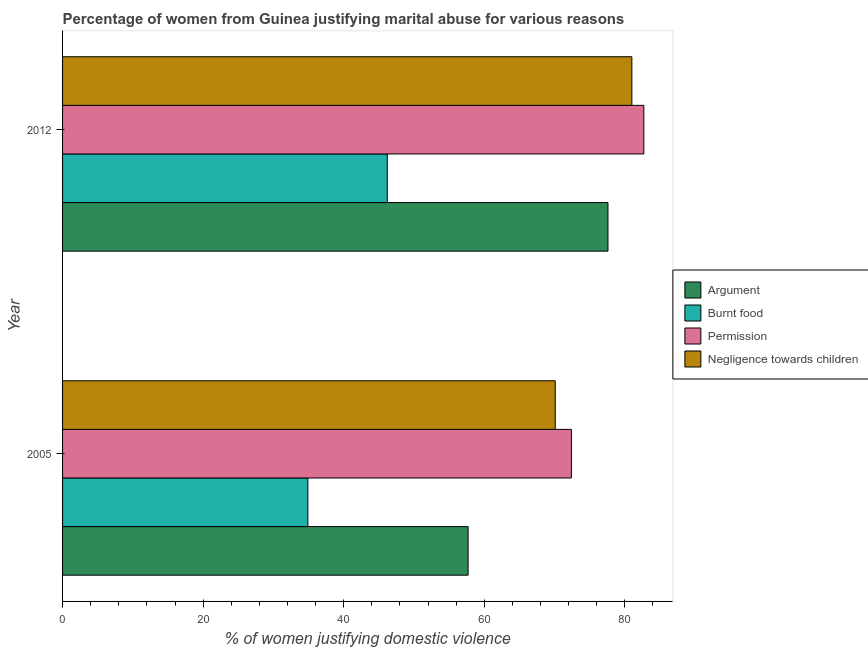How many different coloured bars are there?
Ensure brevity in your answer.  4. How many groups of bars are there?
Make the answer very short. 2. Are the number of bars per tick equal to the number of legend labels?
Your answer should be very brief. Yes. Are the number of bars on each tick of the Y-axis equal?
Give a very brief answer. Yes. How many bars are there on the 1st tick from the top?
Give a very brief answer. 4. How many bars are there on the 1st tick from the bottom?
Provide a short and direct response. 4. What is the label of the 2nd group of bars from the top?
Your answer should be compact. 2005. What is the percentage of women justifying abuse for showing negligence towards children in 2005?
Ensure brevity in your answer.  70.1. Across all years, what is the minimum percentage of women justifying abuse for burning food?
Offer a terse response. 34.9. What is the total percentage of women justifying abuse for burning food in the graph?
Keep it short and to the point. 81.1. What is the difference between the percentage of women justifying abuse in the case of an argument in 2005 and that in 2012?
Provide a short and direct response. -19.9. What is the difference between the percentage of women justifying abuse for showing negligence towards children in 2012 and the percentage of women justifying abuse for going without permission in 2005?
Ensure brevity in your answer.  8.6. What is the average percentage of women justifying abuse in the case of an argument per year?
Ensure brevity in your answer.  67.65. In the year 2012, what is the difference between the percentage of women justifying abuse for burning food and percentage of women justifying abuse in the case of an argument?
Your answer should be compact. -31.4. In how many years, is the percentage of women justifying abuse for showing negligence towards children greater than 52 %?
Your response must be concise. 2. What is the ratio of the percentage of women justifying abuse for burning food in 2005 to that in 2012?
Offer a very short reply. 0.76. What does the 3rd bar from the top in 2005 represents?
Offer a terse response. Burnt food. What does the 2nd bar from the bottom in 2012 represents?
Provide a succinct answer. Burnt food. Is it the case that in every year, the sum of the percentage of women justifying abuse in the case of an argument and percentage of women justifying abuse for burning food is greater than the percentage of women justifying abuse for going without permission?
Provide a succinct answer. Yes. How many years are there in the graph?
Your answer should be compact. 2. What is the difference between two consecutive major ticks on the X-axis?
Ensure brevity in your answer.  20. Where does the legend appear in the graph?
Make the answer very short. Center right. How many legend labels are there?
Keep it short and to the point. 4. What is the title of the graph?
Keep it short and to the point. Percentage of women from Guinea justifying marital abuse for various reasons. What is the label or title of the X-axis?
Provide a succinct answer. % of women justifying domestic violence. What is the % of women justifying domestic violence in Argument in 2005?
Offer a terse response. 57.7. What is the % of women justifying domestic violence in Burnt food in 2005?
Your answer should be very brief. 34.9. What is the % of women justifying domestic violence in Permission in 2005?
Provide a succinct answer. 72.4. What is the % of women justifying domestic violence in Negligence towards children in 2005?
Offer a very short reply. 70.1. What is the % of women justifying domestic violence in Argument in 2012?
Provide a short and direct response. 77.6. What is the % of women justifying domestic violence of Burnt food in 2012?
Provide a short and direct response. 46.2. What is the % of women justifying domestic violence of Permission in 2012?
Ensure brevity in your answer.  82.7. What is the % of women justifying domestic violence of Negligence towards children in 2012?
Offer a very short reply. 81. Across all years, what is the maximum % of women justifying domestic violence in Argument?
Ensure brevity in your answer.  77.6. Across all years, what is the maximum % of women justifying domestic violence in Burnt food?
Provide a succinct answer. 46.2. Across all years, what is the maximum % of women justifying domestic violence of Permission?
Your answer should be compact. 82.7. Across all years, what is the maximum % of women justifying domestic violence of Negligence towards children?
Your answer should be compact. 81. Across all years, what is the minimum % of women justifying domestic violence in Argument?
Your answer should be compact. 57.7. Across all years, what is the minimum % of women justifying domestic violence of Burnt food?
Make the answer very short. 34.9. Across all years, what is the minimum % of women justifying domestic violence in Permission?
Provide a short and direct response. 72.4. Across all years, what is the minimum % of women justifying domestic violence of Negligence towards children?
Keep it short and to the point. 70.1. What is the total % of women justifying domestic violence of Argument in the graph?
Offer a terse response. 135.3. What is the total % of women justifying domestic violence in Burnt food in the graph?
Provide a short and direct response. 81.1. What is the total % of women justifying domestic violence in Permission in the graph?
Your response must be concise. 155.1. What is the total % of women justifying domestic violence in Negligence towards children in the graph?
Offer a very short reply. 151.1. What is the difference between the % of women justifying domestic violence of Argument in 2005 and that in 2012?
Ensure brevity in your answer.  -19.9. What is the difference between the % of women justifying domestic violence in Burnt food in 2005 and that in 2012?
Provide a short and direct response. -11.3. What is the difference between the % of women justifying domestic violence in Negligence towards children in 2005 and that in 2012?
Ensure brevity in your answer.  -10.9. What is the difference between the % of women justifying domestic violence in Argument in 2005 and the % of women justifying domestic violence in Burnt food in 2012?
Offer a terse response. 11.5. What is the difference between the % of women justifying domestic violence in Argument in 2005 and the % of women justifying domestic violence in Negligence towards children in 2012?
Offer a terse response. -23.3. What is the difference between the % of women justifying domestic violence of Burnt food in 2005 and the % of women justifying domestic violence of Permission in 2012?
Offer a terse response. -47.8. What is the difference between the % of women justifying domestic violence in Burnt food in 2005 and the % of women justifying domestic violence in Negligence towards children in 2012?
Give a very brief answer. -46.1. What is the difference between the % of women justifying domestic violence of Permission in 2005 and the % of women justifying domestic violence of Negligence towards children in 2012?
Provide a succinct answer. -8.6. What is the average % of women justifying domestic violence of Argument per year?
Offer a terse response. 67.65. What is the average % of women justifying domestic violence in Burnt food per year?
Provide a succinct answer. 40.55. What is the average % of women justifying domestic violence in Permission per year?
Your response must be concise. 77.55. What is the average % of women justifying domestic violence in Negligence towards children per year?
Ensure brevity in your answer.  75.55. In the year 2005, what is the difference between the % of women justifying domestic violence in Argument and % of women justifying domestic violence in Burnt food?
Keep it short and to the point. 22.8. In the year 2005, what is the difference between the % of women justifying domestic violence of Argument and % of women justifying domestic violence of Permission?
Your response must be concise. -14.7. In the year 2005, what is the difference between the % of women justifying domestic violence in Argument and % of women justifying domestic violence in Negligence towards children?
Make the answer very short. -12.4. In the year 2005, what is the difference between the % of women justifying domestic violence of Burnt food and % of women justifying domestic violence of Permission?
Provide a short and direct response. -37.5. In the year 2005, what is the difference between the % of women justifying domestic violence in Burnt food and % of women justifying domestic violence in Negligence towards children?
Make the answer very short. -35.2. In the year 2012, what is the difference between the % of women justifying domestic violence in Argument and % of women justifying domestic violence in Burnt food?
Keep it short and to the point. 31.4. In the year 2012, what is the difference between the % of women justifying domestic violence in Argument and % of women justifying domestic violence in Permission?
Make the answer very short. -5.1. In the year 2012, what is the difference between the % of women justifying domestic violence in Argument and % of women justifying domestic violence in Negligence towards children?
Keep it short and to the point. -3.4. In the year 2012, what is the difference between the % of women justifying domestic violence in Burnt food and % of women justifying domestic violence in Permission?
Make the answer very short. -36.5. In the year 2012, what is the difference between the % of women justifying domestic violence in Burnt food and % of women justifying domestic violence in Negligence towards children?
Ensure brevity in your answer.  -34.8. What is the ratio of the % of women justifying domestic violence in Argument in 2005 to that in 2012?
Keep it short and to the point. 0.74. What is the ratio of the % of women justifying domestic violence of Burnt food in 2005 to that in 2012?
Make the answer very short. 0.76. What is the ratio of the % of women justifying domestic violence of Permission in 2005 to that in 2012?
Provide a succinct answer. 0.88. What is the ratio of the % of women justifying domestic violence of Negligence towards children in 2005 to that in 2012?
Ensure brevity in your answer.  0.87. What is the difference between the highest and the second highest % of women justifying domestic violence in Argument?
Your response must be concise. 19.9. What is the difference between the highest and the second highest % of women justifying domestic violence of Permission?
Keep it short and to the point. 10.3. What is the difference between the highest and the lowest % of women justifying domestic violence in Burnt food?
Your answer should be very brief. 11.3. What is the difference between the highest and the lowest % of women justifying domestic violence in Negligence towards children?
Keep it short and to the point. 10.9. 